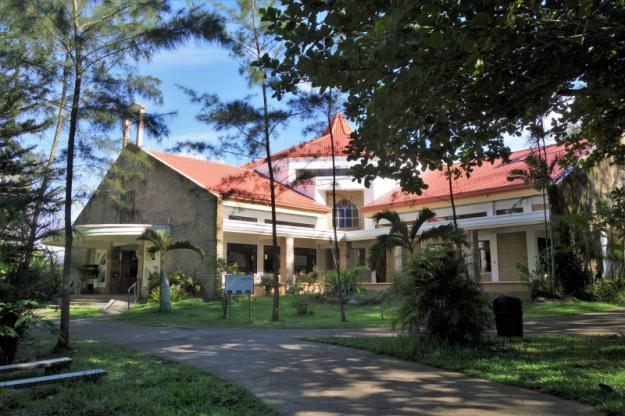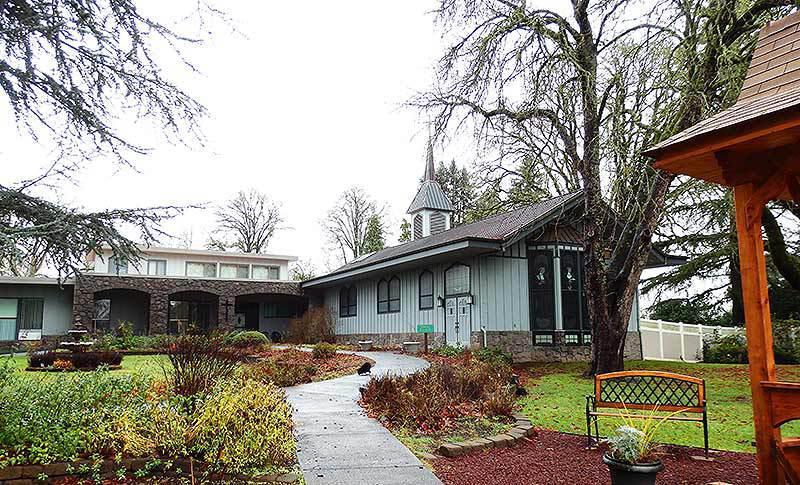The first image is the image on the left, the second image is the image on the right. Given the left and right images, does the statement "At least one image shows a seating area along a row of archways that overlooks a garden area." hold true? Answer yes or no. No. 